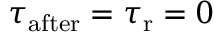<formula> <loc_0><loc_0><loc_500><loc_500>\tau _ { a f t e r } = \tau _ { r } = 0</formula> 